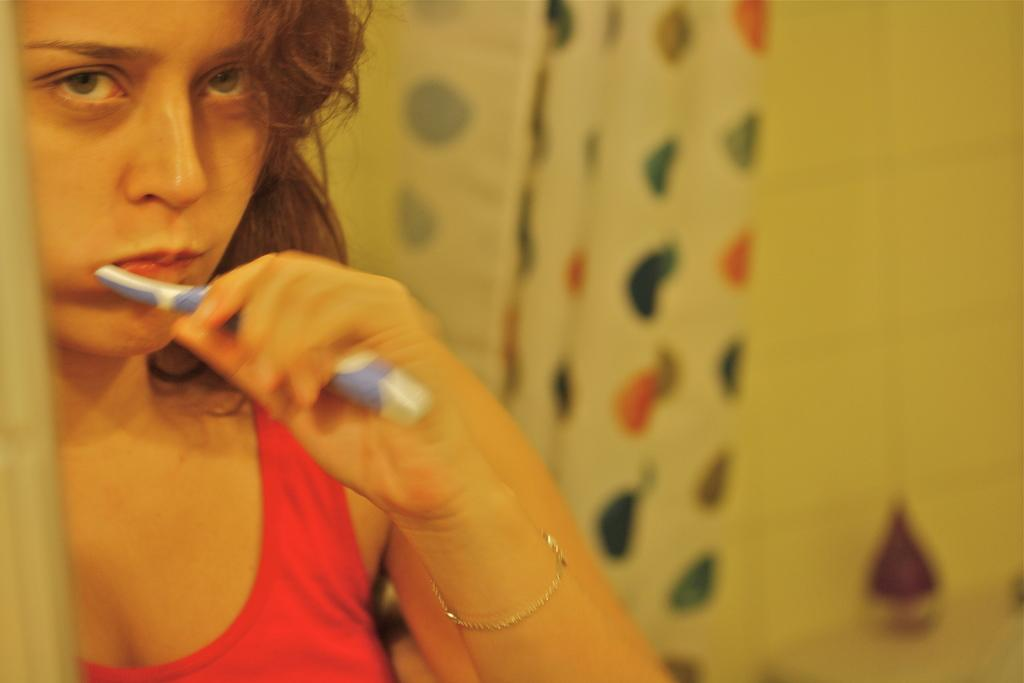Who is the main subject in the image? There is a woman in the image. What is the woman wearing? The woman is wearing a red tank top. What object is the woman holding? The woman is holding a toothbrush. Can you describe the background of the image? The background of the image is blurred. What type of pies can be seen in the image? There are no pies present in the image. Are there any bushes visible in the background of the image? There is no mention of bushes in the provided facts, and the background is blurred, so it is impossible to determine if bushes are present. 